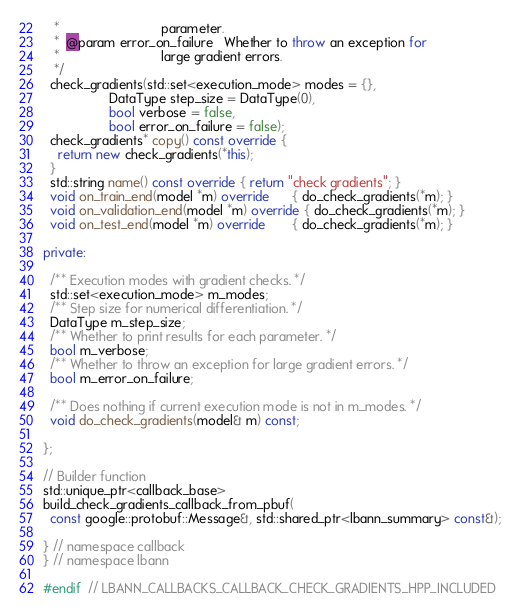<code> <loc_0><loc_0><loc_500><loc_500><_C++_>   *                            parameter.
   *  @param error_on_failure   Whether to throw an exception for
   *                            large gradient errors.
   */
  check_gradients(std::set<execution_mode> modes = {},
                  DataType step_size = DataType(0),
                  bool verbose = false,
                  bool error_on_failure = false);
  check_gradients* copy() const override {
    return new check_gradients(*this);
  }
  std::string name() const override { return "check gradients"; }
  void on_train_end(model *m) override      { do_check_gradients(*m); }
  void on_validation_end(model *m) override { do_check_gradients(*m); }
  void on_test_end(model *m) override       { do_check_gradients(*m); }

private:

  /** Execution modes with gradient checks. */
  std::set<execution_mode> m_modes;
  /** Step size for numerical differentiation. */
  DataType m_step_size;
  /** Whether to print results for each parameter. */
  bool m_verbose;
  /** Whether to throw an exception for large gradient errors. */
  bool m_error_on_failure;

  /** Does nothing if current execution mode is not in m_modes. */
  void do_check_gradients(model& m) const;

};

// Builder function
std::unique_ptr<callback_base>
build_check_gradients_callback_from_pbuf(
  const google::protobuf::Message&, std::shared_ptr<lbann_summary> const&);

} // namespace callback
} // namespace lbann

#endif  // LBANN_CALLBACKS_CALLBACK_CHECK_GRADIENTS_HPP_INCLUDED
</code> 